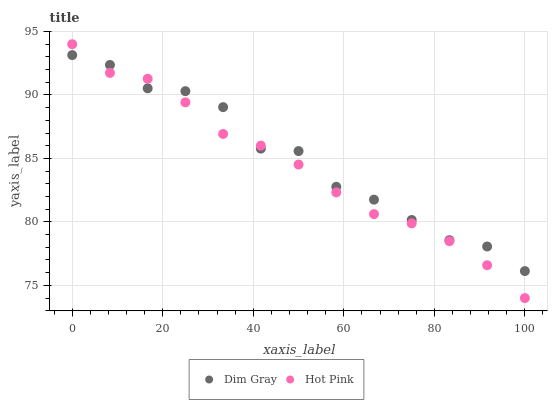Does Hot Pink have the minimum area under the curve?
Answer yes or no. Yes. Does Dim Gray have the maximum area under the curve?
Answer yes or no. Yes. Does Hot Pink have the maximum area under the curve?
Answer yes or no. No. Is Hot Pink the smoothest?
Answer yes or no. Yes. Is Dim Gray the roughest?
Answer yes or no. Yes. Is Hot Pink the roughest?
Answer yes or no. No. Does Hot Pink have the lowest value?
Answer yes or no. Yes. Does Hot Pink have the highest value?
Answer yes or no. Yes. Does Dim Gray intersect Hot Pink?
Answer yes or no. Yes. Is Dim Gray less than Hot Pink?
Answer yes or no. No. Is Dim Gray greater than Hot Pink?
Answer yes or no. No. 